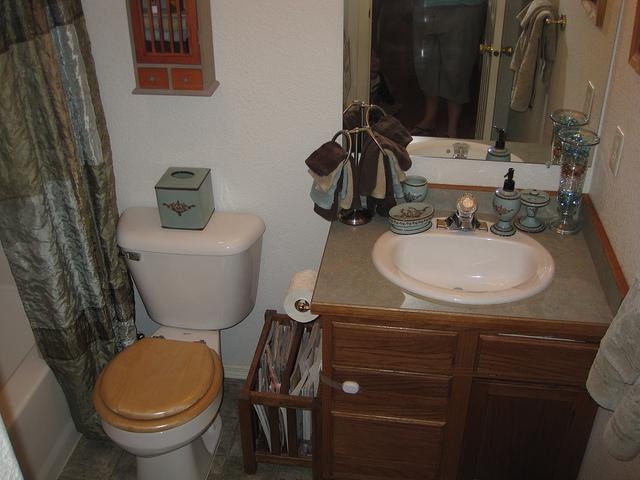What color is the tissue box on the top of the toilet bowl? Please explain your reasoning. blue. The tissue box is not yellow, purple, or red. 